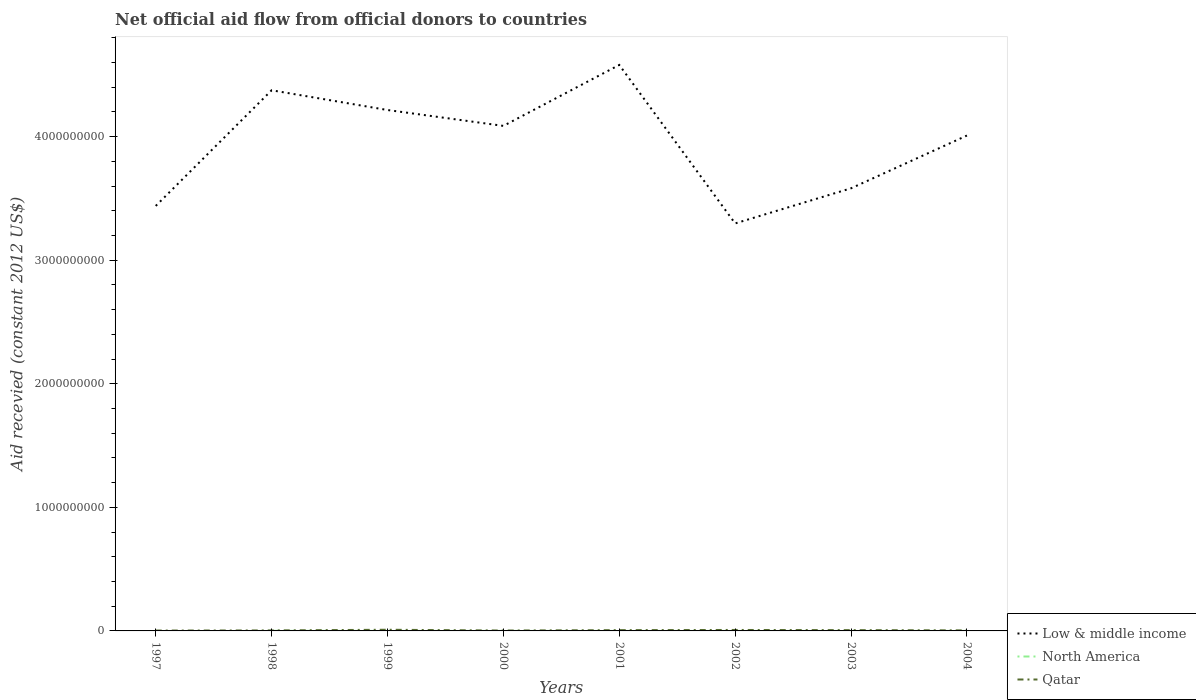Does the line corresponding to North America intersect with the line corresponding to Qatar?
Give a very brief answer. No. Across all years, what is the maximum total aid received in Qatar?
Make the answer very short. 2.98e+06. What is the total total aid received in Low & middle income in the graph?
Your response must be concise. 1.29e+08. What is the difference between the highest and the second highest total aid received in Qatar?
Your answer should be very brief. 6.53e+06. What is the difference between the highest and the lowest total aid received in Qatar?
Offer a very short reply. 4. Is the total aid received in Low & middle income strictly greater than the total aid received in North America over the years?
Your answer should be compact. No. How many years are there in the graph?
Give a very brief answer. 8. How many legend labels are there?
Ensure brevity in your answer.  3. What is the title of the graph?
Offer a very short reply. Net official aid flow from official donors to countries. What is the label or title of the Y-axis?
Ensure brevity in your answer.  Aid recevied (constant 2012 US$). What is the Aid recevied (constant 2012 US$) of Low & middle income in 1997?
Provide a short and direct response. 3.44e+09. What is the Aid recevied (constant 2012 US$) of North America in 1997?
Keep it short and to the point. 0. What is the Aid recevied (constant 2012 US$) of Qatar in 1997?
Offer a terse response. 2.98e+06. What is the Aid recevied (constant 2012 US$) in Low & middle income in 1998?
Your answer should be compact. 4.38e+09. What is the Aid recevied (constant 2012 US$) in North America in 1998?
Ensure brevity in your answer.  7.40e+05. What is the Aid recevied (constant 2012 US$) in Qatar in 1998?
Keep it short and to the point. 3.90e+06. What is the Aid recevied (constant 2012 US$) of Low & middle income in 1999?
Your response must be concise. 4.22e+09. What is the Aid recevied (constant 2012 US$) of North America in 1999?
Provide a succinct answer. 1.30e+05. What is the Aid recevied (constant 2012 US$) in Qatar in 1999?
Provide a succinct answer. 9.51e+06. What is the Aid recevied (constant 2012 US$) of Low & middle income in 2000?
Provide a succinct answer. 4.09e+09. What is the Aid recevied (constant 2012 US$) of Qatar in 2000?
Your answer should be very brief. 3.14e+06. What is the Aid recevied (constant 2012 US$) of Low & middle income in 2001?
Make the answer very short. 4.58e+09. What is the Aid recevied (constant 2012 US$) of North America in 2001?
Ensure brevity in your answer.  4.00e+04. What is the Aid recevied (constant 2012 US$) of Qatar in 2001?
Your answer should be compact. 6.30e+06. What is the Aid recevied (constant 2012 US$) of Low & middle income in 2002?
Offer a terse response. 3.30e+09. What is the Aid recevied (constant 2012 US$) in North America in 2002?
Offer a terse response. 3.00e+04. What is the Aid recevied (constant 2012 US$) of Qatar in 2002?
Offer a terse response. 7.79e+06. What is the Aid recevied (constant 2012 US$) of Low & middle income in 2003?
Offer a very short reply. 3.58e+09. What is the Aid recevied (constant 2012 US$) of North America in 2003?
Ensure brevity in your answer.  4.00e+04. What is the Aid recevied (constant 2012 US$) in Qatar in 2003?
Provide a short and direct response. 6.38e+06. What is the Aid recevied (constant 2012 US$) of Low & middle income in 2004?
Your response must be concise. 4.01e+09. What is the Aid recevied (constant 2012 US$) of Qatar in 2004?
Keep it short and to the point. 4.35e+06. Across all years, what is the maximum Aid recevied (constant 2012 US$) of Low & middle income?
Provide a succinct answer. 4.58e+09. Across all years, what is the maximum Aid recevied (constant 2012 US$) in North America?
Provide a short and direct response. 7.40e+05. Across all years, what is the maximum Aid recevied (constant 2012 US$) in Qatar?
Your response must be concise. 9.51e+06. Across all years, what is the minimum Aid recevied (constant 2012 US$) in Low & middle income?
Offer a terse response. 3.30e+09. Across all years, what is the minimum Aid recevied (constant 2012 US$) of North America?
Offer a terse response. 0. Across all years, what is the minimum Aid recevied (constant 2012 US$) of Qatar?
Give a very brief answer. 2.98e+06. What is the total Aid recevied (constant 2012 US$) of Low & middle income in the graph?
Offer a very short reply. 3.16e+1. What is the total Aid recevied (constant 2012 US$) in North America in the graph?
Your answer should be very brief. 1.20e+06. What is the total Aid recevied (constant 2012 US$) of Qatar in the graph?
Keep it short and to the point. 4.44e+07. What is the difference between the Aid recevied (constant 2012 US$) in Low & middle income in 1997 and that in 1998?
Ensure brevity in your answer.  -9.36e+08. What is the difference between the Aid recevied (constant 2012 US$) of Qatar in 1997 and that in 1998?
Give a very brief answer. -9.20e+05. What is the difference between the Aid recevied (constant 2012 US$) of Low & middle income in 1997 and that in 1999?
Offer a very short reply. -7.76e+08. What is the difference between the Aid recevied (constant 2012 US$) in Qatar in 1997 and that in 1999?
Make the answer very short. -6.53e+06. What is the difference between the Aid recevied (constant 2012 US$) in Low & middle income in 1997 and that in 2000?
Make the answer very short. -6.48e+08. What is the difference between the Aid recevied (constant 2012 US$) of Qatar in 1997 and that in 2000?
Offer a terse response. -1.60e+05. What is the difference between the Aid recevied (constant 2012 US$) of Low & middle income in 1997 and that in 2001?
Your response must be concise. -1.14e+09. What is the difference between the Aid recevied (constant 2012 US$) of Qatar in 1997 and that in 2001?
Your answer should be very brief. -3.32e+06. What is the difference between the Aid recevied (constant 2012 US$) in Low & middle income in 1997 and that in 2002?
Offer a very short reply. 1.42e+08. What is the difference between the Aid recevied (constant 2012 US$) in Qatar in 1997 and that in 2002?
Offer a very short reply. -4.81e+06. What is the difference between the Aid recevied (constant 2012 US$) of Low & middle income in 1997 and that in 2003?
Make the answer very short. -1.43e+08. What is the difference between the Aid recevied (constant 2012 US$) of Qatar in 1997 and that in 2003?
Offer a very short reply. -3.40e+06. What is the difference between the Aid recevied (constant 2012 US$) of Low & middle income in 1997 and that in 2004?
Provide a succinct answer. -5.70e+08. What is the difference between the Aid recevied (constant 2012 US$) in Qatar in 1997 and that in 2004?
Keep it short and to the point. -1.37e+06. What is the difference between the Aid recevied (constant 2012 US$) of Low & middle income in 1998 and that in 1999?
Offer a very short reply. 1.60e+08. What is the difference between the Aid recevied (constant 2012 US$) in Qatar in 1998 and that in 1999?
Provide a short and direct response. -5.61e+06. What is the difference between the Aid recevied (constant 2012 US$) in Low & middle income in 1998 and that in 2000?
Provide a short and direct response. 2.88e+08. What is the difference between the Aid recevied (constant 2012 US$) in North America in 1998 and that in 2000?
Make the answer very short. 6.30e+05. What is the difference between the Aid recevied (constant 2012 US$) of Qatar in 1998 and that in 2000?
Your response must be concise. 7.60e+05. What is the difference between the Aid recevied (constant 2012 US$) of Low & middle income in 1998 and that in 2001?
Your answer should be compact. -2.05e+08. What is the difference between the Aid recevied (constant 2012 US$) of Qatar in 1998 and that in 2001?
Give a very brief answer. -2.40e+06. What is the difference between the Aid recevied (constant 2012 US$) in Low & middle income in 1998 and that in 2002?
Your response must be concise. 1.08e+09. What is the difference between the Aid recevied (constant 2012 US$) in North America in 1998 and that in 2002?
Keep it short and to the point. 7.10e+05. What is the difference between the Aid recevied (constant 2012 US$) in Qatar in 1998 and that in 2002?
Offer a very short reply. -3.89e+06. What is the difference between the Aid recevied (constant 2012 US$) in Low & middle income in 1998 and that in 2003?
Offer a terse response. 7.93e+08. What is the difference between the Aid recevied (constant 2012 US$) of Qatar in 1998 and that in 2003?
Make the answer very short. -2.48e+06. What is the difference between the Aid recevied (constant 2012 US$) of Low & middle income in 1998 and that in 2004?
Your answer should be very brief. 3.66e+08. What is the difference between the Aid recevied (constant 2012 US$) in North America in 1998 and that in 2004?
Keep it short and to the point. 6.30e+05. What is the difference between the Aid recevied (constant 2012 US$) in Qatar in 1998 and that in 2004?
Ensure brevity in your answer.  -4.50e+05. What is the difference between the Aid recevied (constant 2012 US$) of Low & middle income in 1999 and that in 2000?
Ensure brevity in your answer.  1.29e+08. What is the difference between the Aid recevied (constant 2012 US$) of Qatar in 1999 and that in 2000?
Your response must be concise. 6.37e+06. What is the difference between the Aid recevied (constant 2012 US$) of Low & middle income in 1999 and that in 2001?
Provide a short and direct response. -3.65e+08. What is the difference between the Aid recevied (constant 2012 US$) in North America in 1999 and that in 2001?
Ensure brevity in your answer.  9.00e+04. What is the difference between the Aid recevied (constant 2012 US$) in Qatar in 1999 and that in 2001?
Make the answer very short. 3.21e+06. What is the difference between the Aid recevied (constant 2012 US$) in Low & middle income in 1999 and that in 2002?
Make the answer very short. 9.18e+08. What is the difference between the Aid recevied (constant 2012 US$) in North America in 1999 and that in 2002?
Ensure brevity in your answer.  1.00e+05. What is the difference between the Aid recevied (constant 2012 US$) of Qatar in 1999 and that in 2002?
Your answer should be very brief. 1.72e+06. What is the difference between the Aid recevied (constant 2012 US$) in Low & middle income in 1999 and that in 2003?
Ensure brevity in your answer.  6.34e+08. What is the difference between the Aid recevied (constant 2012 US$) of North America in 1999 and that in 2003?
Ensure brevity in your answer.  9.00e+04. What is the difference between the Aid recevied (constant 2012 US$) of Qatar in 1999 and that in 2003?
Provide a short and direct response. 3.13e+06. What is the difference between the Aid recevied (constant 2012 US$) of Low & middle income in 1999 and that in 2004?
Offer a terse response. 2.07e+08. What is the difference between the Aid recevied (constant 2012 US$) in North America in 1999 and that in 2004?
Offer a very short reply. 2.00e+04. What is the difference between the Aid recevied (constant 2012 US$) of Qatar in 1999 and that in 2004?
Offer a terse response. 5.16e+06. What is the difference between the Aid recevied (constant 2012 US$) in Low & middle income in 2000 and that in 2001?
Keep it short and to the point. -4.93e+08. What is the difference between the Aid recevied (constant 2012 US$) in Qatar in 2000 and that in 2001?
Provide a succinct answer. -3.16e+06. What is the difference between the Aid recevied (constant 2012 US$) of Low & middle income in 2000 and that in 2002?
Give a very brief answer. 7.89e+08. What is the difference between the Aid recevied (constant 2012 US$) in Qatar in 2000 and that in 2002?
Make the answer very short. -4.65e+06. What is the difference between the Aid recevied (constant 2012 US$) of Low & middle income in 2000 and that in 2003?
Keep it short and to the point. 5.05e+08. What is the difference between the Aid recevied (constant 2012 US$) in Qatar in 2000 and that in 2003?
Provide a short and direct response. -3.24e+06. What is the difference between the Aid recevied (constant 2012 US$) of Low & middle income in 2000 and that in 2004?
Provide a short and direct response. 7.80e+07. What is the difference between the Aid recevied (constant 2012 US$) of North America in 2000 and that in 2004?
Make the answer very short. 0. What is the difference between the Aid recevied (constant 2012 US$) of Qatar in 2000 and that in 2004?
Provide a short and direct response. -1.21e+06. What is the difference between the Aid recevied (constant 2012 US$) of Low & middle income in 2001 and that in 2002?
Your response must be concise. 1.28e+09. What is the difference between the Aid recevied (constant 2012 US$) in Qatar in 2001 and that in 2002?
Provide a succinct answer. -1.49e+06. What is the difference between the Aid recevied (constant 2012 US$) of Low & middle income in 2001 and that in 2003?
Ensure brevity in your answer.  9.98e+08. What is the difference between the Aid recevied (constant 2012 US$) in North America in 2001 and that in 2003?
Provide a short and direct response. 0. What is the difference between the Aid recevied (constant 2012 US$) of Qatar in 2001 and that in 2003?
Ensure brevity in your answer.  -8.00e+04. What is the difference between the Aid recevied (constant 2012 US$) of Low & middle income in 2001 and that in 2004?
Ensure brevity in your answer.  5.71e+08. What is the difference between the Aid recevied (constant 2012 US$) of North America in 2001 and that in 2004?
Provide a short and direct response. -7.00e+04. What is the difference between the Aid recevied (constant 2012 US$) in Qatar in 2001 and that in 2004?
Offer a terse response. 1.95e+06. What is the difference between the Aid recevied (constant 2012 US$) of Low & middle income in 2002 and that in 2003?
Make the answer very short. -2.84e+08. What is the difference between the Aid recevied (constant 2012 US$) of Qatar in 2002 and that in 2003?
Your answer should be very brief. 1.41e+06. What is the difference between the Aid recevied (constant 2012 US$) of Low & middle income in 2002 and that in 2004?
Your answer should be very brief. -7.11e+08. What is the difference between the Aid recevied (constant 2012 US$) of North America in 2002 and that in 2004?
Give a very brief answer. -8.00e+04. What is the difference between the Aid recevied (constant 2012 US$) in Qatar in 2002 and that in 2004?
Your answer should be very brief. 3.44e+06. What is the difference between the Aid recevied (constant 2012 US$) of Low & middle income in 2003 and that in 2004?
Offer a terse response. -4.27e+08. What is the difference between the Aid recevied (constant 2012 US$) in North America in 2003 and that in 2004?
Your answer should be very brief. -7.00e+04. What is the difference between the Aid recevied (constant 2012 US$) in Qatar in 2003 and that in 2004?
Offer a very short reply. 2.03e+06. What is the difference between the Aid recevied (constant 2012 US$) in Low & middle income in 1997 and the Aid recevied (constant 2012 US$) in North America in 1998?
Your response must be concise. 3.44e+09. What is the difference between the Aid recevied (constant 2012 US$) of Low & middle income in 1997 and the Aid recevied (constant 2012 US$) of Qatar in 1998?
Provide a succinct answer. 3.44e+09. What is the difference between the Aid recevied (constant 2012 US$) in Low & middle income in 1997 and the Aid recevied (constant 2012 US$) in North America in 1999?
Your response must be concise. 3.44e+09. What is the difference between the Aid recevied (constant 2012 US$) of Low & middle income in 1997 and the Aid recevied (constant 2012 US$) of Qatar in 1999?
Your answer should be compact. 3.43e+09. What is the difference between the Aid recevied (constant 2012 US$) of Low & middle income in 1997 and the Aid recevied (constant 2012 US$) of North America in 2000?
Your answer should be compact. 3.44e+09. What is the difference between the Aid recevied (constant 2012 US$) of Low & middle income in 1997 and the Aid recevied (constant 2012 US$) of Qatar in 2000?
Make the answer very short. 3.44e+09. What is the difference between the Aid recevied (constant 2012 US$) of Low & middle income in 1997 and the Aid recevied (constant 2012 US$) of North America in 2001?
Give a very brief answer. 3.44e+09. What is the difference between the Aid recevied (constant 2012 US$) of Low & middle income in 1997 and the Aid recevied (constant 2012 US$) of Qatar in 2001?
Offer a terse response. 3.43e+09. What is the difference between the Aid recevied (constant 2012 US$) of Low & middle income in 1997 and the Aid recevied (constant 2012 US$) of North America in 2002?
Ensure brevity in your answer.  3.44e+09. What is the difference between the Aid recevied (constant 2012 US$) in Low & middle income in 1997 and the Aid recevied (constant 2012 US$) in Qatar in 2002?
Your response must be concise. 3.43e+09. What is the difference between the Aid recevied (constant 2012 US$) of Low & middle income in 1997 and the Aid recevied (constant 2012 US$) of North America in 2003?
Offer a very short reply. 3.44e+09. What is the difference between the Aid recevied (constant 2012 US$) in Low & middle income in 1997 and the Aid recevied (constant 2012 US$) in Qatar in 2003?
Keep it short and to the point. 3.43e+09. What is the difference between the Aid recevied (constant 2012 US$) in Low & middle income in 1997 and the Aid recevied (constant 2012 US$) in North America in 2004?
Your answer should be compact. 3.44e+09. What is the difference between the Aid recevied (constant 2012 US$) in Low & middle income in 1997 and the Aid recevied (constant 2012 US$) in Qatar in 2004?
Keep it short and to the point. 3.43e+09. What is the difference between the Aid recevied (constant 2012 US$) of Low & middle income in 1998 and the Aid recevied (constant 2012 US$) of North America in 1999?
Your answer should be very brief. 4.38e+09. What is the difference between the Aid recevied (constant 2012 US$) of Low & middle income in 1998 and the Aid recevied (constant 2012 US$) of Qatar in 1999?
Make the answer very short. 4.37e+09. What is the difference between the Aid recevied (constant 2012 US$) in North America in 1998 and the Aid recevied (constant 2012 US$) in Qatar in 1999?
Keep it short and to the point. -8.77e+06. What is the difference between the Aid recevied (constant 2012 US$) of Low & middle income in 1998 and the Aid recevied (constant 2012 US$) of North America in 2000?
Provide a succinct answer. 4.38e+09. What is the difference between the Aid recevied (constant 2012 US$) in Low & middle income in 1998 and the Aid recevied (constant 2012 US$) in Qatar in 2000?
Provide a succinct answer. 4.37e+09. What is the difference between the Aid recevied (constant 2012 US$) of North America in 1998 and the Aid recevied (constant 2012 US$) of Qatar in 2000?
Offer a terse response. -2.40e+06. What is the difference between the Aid recevied (constant 2012 US$) of Low & middle income in 1998 and the Aid recevied (constant 2012 US$) of North America in 2001?
Your answer should be compact. 4.38e+09. What is the difference between the Aid recevied (constant 2012 US$) in Low & middle income in 1998 and the Aid recevied (constant 2012 US$) in Qatar in 2001?
Provide a short and direct response. 4.37e+09. What is the difference between the Aid recevied (constant 2012 US$) of North America in 1998 and the Aid recevied (constant 2012 US$) of Qatar in 2001?
Your response must be concise. -5.56e+06. What is the difference between the Aid recevied (constant 2012 US$) in Low & middle income in 1998 and the Aid recevied (constant 2012 US$) in North America in 2002?
Ensure brevity in your answer.  4.38e+09. What is the difference between the Aid recevied (constant 2012 US$) in Low & middle income in 1998 and the Aid recevied (constant 2012 US$) in Qatar in 2002?
Offer a very short reply. 4.37e+09. What is the difference between the Aid recevied (constant 2012 US$) of North America in 1998 and the Aid recevied (constant 2012 US$) of Qatar in 2002?
Offer a very short reply. -7.05e+06. What is the difference between the Aid recevied (constant 2012 US$) of Low & middle income in 1998 and the Aid recevied (constant 2012 US$) of North America in 2003?
Ensure brevity in your answer.  4.38e+09. What is the difference between the Aid recevied (constant 2012 US$) of Low & middle income in 1998 and the Aid recevied (constant 2012 US$) of Qatar in 2003?
Offer a very short reply. 4.37e+09. What is the difference between the Aid recevied (constant 2012 US$) of North America in 1998 and the Aid recevied (constant 2012 US$) of Qatar in 2003?
Your answer should be very brief. -5.64e+06. What is the difference between the Aid recevied (constant 2012 US$) in Low & middle income in 1998 and the Aid recevied (constant 2012 US$) in North America in 2004?
Ensure brevity in your answer.  4.38e+09. What is the difference between the Aid recevied (constant 2012 US$) of Low & middle income in 1998 and the Aid recevied (constant 2012 US$) of Qatar in 2004?
Your answer should be very brief. 4.37e+09. What is the difference between the Aid recevied (constant 2012 US$) in North America in 1998 and the Aid recevied (constant 2012 US$) in Qatar in 2004?
Offer a very short reply. -3.61e+06. What is the difference between the Aid recevied (constant 2012 US$) in Low & middle income in 1999 and the Aid recevied (constant 2012 US$) in North America in 2000?
Provide a succinct answer. 4.22e+09. What is the difference between the Aid recevied (constant 2012 US$) of Low & middle income in 1999 and the Aid recevied (constant 2012 US$) of Qatar in 2000?
Your answer should be compact. 4.21e+09. What is the difference between the Aid recevied (constant 2012 US$) in North America in 1999 and the Aid recevied (constant 2012 US$) in Qatar in 2000?
Your answer should be very brief. -3.01e+06. What is the difference between the Aid recevied (constant 2012 US$) in Low & middle income in 1999 and the Aid recevied (constant 2012 US$) in North America in 2001?
Make the answer very short. 4.22e+09. What is the difference between the Aid recevied (constant 2012 US$) of Low & middle income in 1999 and the Aid recevied (constant 2012 US$) of Qatar in 2001?
Offer a very short reply. 4.21e+09. What is the difference between the Aid recevied (constant 2012 US$) of North America in 1999 and the Aid recevied (constant 2012 US$) of Qatar in 2001?
Offer a very short reply. -6.17e+06. What is the difference between the Aid recevied (constant 2012 US$) in Low & middle income in 1999 and the Aid recevied (constant 2012 US$) in North America in 2002?
Your response must be concise. 4.22e+09. What is the difference between the Aid recevied (constant 2012 US$) of Low & middle income in 1999 and the Aid recevied (constant 2012 US$) of Qatar in 2002?
Give a very brief answer. 4.21e+09. What is the difference between the Aid recevied (constant 2012 US$) in North America in 1999 and the Aid recevied (constant 2012 US$) in Qatar in 2002?
Your answer should be compact. -7.66e+06. What is the difference between the Aid recevied (constant 2012 US$) in Low & middle income in 1999 and the Aid recevied (constant 2012 US$) in North America in 2003?
Give a very brief answer. 4.22e+09. What is the difference between the Aid recevied (constant 2012 US$) of Low & middle income in 1999 and the Aid recevied (constant 2012 US$) of Qatar in 2003?
Keep it short and to the point. 4.21e+09. What is the difference between the Aid recevied (constant 2012 US$) of North America in 1999 and the Aid recevied (constant 2012 US$) of Qatar in 2003?
Provide a succinct answer. -6.25e+06. What is the difference between the Aid recevied (constant 2012 US$) of Low & middle income in 1999 and the Aid recevied (constant 2012 US$) of North America in 2004?
Provide a succinct answer. 4.22e+09. What is the difference between the Aid recevied (constant 2012 US$) in Low & middle income in 1999 and the Aid recevied (constant 2012 US$) in Qatar in 2004?
Your answer should be very brief. 4.21e+09. What is the difference between the Aid recevied (constant 2012 US$) in North America in 1999 and the Aid recevied (constant 2012 US$) in Qatar in 2004?
Keep it short and to the point. -4.22e+06. What is the difference between the Aid recevied (constant 2012 US$) in Low & middle income in 2000 and the Aid recevied (constant 2012 US$) in North America in 2001?
Keep it short and to the point. 4.09e+09. What is the difference between the Aid recevied (constant 2012 US$) of Low & middle income in 2000 and the Aid recevied (constant 2012 US$) of Qatar in 2001?
Provide a short and direct response. 4.08e+09. What is the difference between the Aid recevied (constant 2012 US$) of North America in 2000 and the Aid recevied (constant 2012 US$) of Qatar in 2001?
Your answer should be compact. -6.19e+06. What is the difference between the Aid recevied (constant 2012 US$) in Low & middle income in 2000 and the Aid recevied (constant 2012 US$) in North America in 2002?
Offer a very short reply. 4.09e+09. What is the difference between the Aid recevied (constant 2012 US$) of Low & middle income in 2000 and the Aid recevied (constant 2012 US$) of Qatar in 2002?
Your response must be concise. 4.08e+09. What is the difference between the Aid recevied (constant 2012 US$) in North America in 2000 and the Aid recevied (constant 2012 US$) in Qatar in 2002?
Your answer should be compact. -7.68e+06. What is the difference between the Aid recevied (constant 2012 US$) in Low & middle income in 2000 and the Aid recevied (constant 2012 US$) in North America in 2003?
Your answer should be very brief. 4.09e+09. What is the difference between the Aid recevied (constant 2012 US$) of Low & middle income in 2000 and the Aid recevied (constant 2012 US$) of Qatar in 2003?
Your answer should be very brief. 4.08e+09. What is the difference between the Aid recevied (constant 2012 US$) in North America in 2000 and the Aid recevied (constant 2012 US$) in Qatar in 2003?
Ensure brevity in your answer.  -6.27e+06. What is the difference between the Aid recevied (constant 2012 US$) in Low & middle income in 2000 and the Aid recevied (constant 2012 US$) in North America in 2004?
Provide a short and direct response. 4.09e+09. What is the difference between the Aid recevied (constant 2012 US$) in Low & middle income in 2000 and the Aid recevied (constant 2012 US$) in Qatar in 2004?
Your answer should be very brief. 4.08e+09. What is the difference between the Aid recevied (constant 2012 US$) of North America in 2000 and the Aid recevied (constant 2012 US$) of Qatar in 2004?
Keep it short and to the point. -4.24e+06. What is the difference between the Aid recevied (constant 2012 US$) in Low & middle income in 2001 and the Aid recevied (constant 2012 US$) in North America in 2002?
Give a very brief answer. 4.58e+09. What is the difference between the Aid recevied (constant 2012 US$) of Low & middle income in 2001 and the Aid recevied (constant 2012 US$) of Qatar in 2002?
Your response must be concise. 4.57e+09. What is the difference between the Aid recevied (constant 2012 US$) of North America in 2001 and the Aid recevied (constant 2012 US$) of Qatar in 2002?
Your response must be concise. -7.75e+06. What is the difference between the Aid recevied (constant 2012 US$) of Low & middle income in 2001 and the Aid recevied (constant 2012 US$) of North America in 2003?
Offer a terse response. 4.58e+09. What is the difference between the Aid recevied (constant 2012 US$) in Low & middle income in 2001 and the Aid recevied (constant 2012 US$) in Qatar in 2003?
Offer a terse response. 4.57e+09. What is the difference between the Aid recevied (constant 2012 US$) of North America in 2001 and the Aid recevied (constant 2012 US$) of Qatar in 2003?
Offer a very short reply. -6.34e+06. What is the difference between the Aid recevied (constant 2012 US$) of Low & middle income in 2001 and the Aid recevied (constant 2012 US$) of North America in 2004?
Provide a short and direct response. 4.58e+09. What is the difference between the Aid recevied (constant 2012 US$) in Low & middle income in 2001 and the Aid recevied (constant 2012 US$) in Qatar in 2004?
Keep it short and to the point. 4.58e+09. What is the difference between the Aid recevied (constant 2012 US$) in North America in 2001 and the Aid recevied (constant 2012 US$) in Qatar in 2004?
Keep it short and to the point. -4.31e+06. What is the difference between the Aid recevied (constant 2012 US$) of Low & middle income in 2002 and the Aid recevied (constant 2012 US$) of North America in 2003?
Make the answer very short. 3.30e+09. What is the difference between the Aid recevied (constant 2012 US$) in Low & middle income in 2002 and the Aid recevied (constant 2012 US$) in Qatar in 2003?
Your answer should be very brief. 3.29e+09. What is the difference between the Aid recevied (constant 2012 US$) of North America in 2002 and the Aid recevied (constant 2012 US$) of Qatar in 2003?
Your answer should be compact. -6.35e+06. What is the difference between the Aid recevied (constant 2012 US$) in Low & middle income in 2002 and the Aid recevied (constant 2012 US$) in North America in 2004?
Give a very brief answer. 3.30e+09. What is the difference between the Aid recevied (constant 2012 US$) in Low & middle income in 2002 and the Aid recevied (constant 2012 US$) in Qatar in 2004?
Keep it short and to the point. 3.29e+09. What is the difference between the Aid recevied (constant 2012 US$) of North America in 2002 and the Aid recevied (constant 2012 US$) of Qatar in 2004?
Provide a short and direct response. -4.32e+06. What is the difference between the Aid recevied (constant 2012 US$) in Low & middle income in 2003 and the Aid recevied (constant 2012 US$) in North America in 2004?
Make the answer very short. 3.58e+09. What is the difference between the Aid recevied (constant 2012 US$) in Low & middle income in 2003 and the Aid recevied (constant 2012 US$) in Qatar in 2004?
Keep it short and to the point. 3.58e+09. What is the difference between the Aid recevied (constant 2012 US$) in North America in 2003 and the Aid recevied (constant 2012 US$) in Qatar in 2004?
Offer a terse response. -4.31e+06. What is the average Aid recevied (constant 2012 US$) of Low & middle income per year?
Make the answer very short. 3.95e+09. What is the average Aid recevied (constant 2012 US$) of North America per year?
Your answer should be compact. 1.50e+05. What is the average Aid recevied (constant 2012 US$) of Qatar per year?
Offer a very short reply. 5.54e+06. In the year 1997, what is the difference between the Aid recevied (constant 2012 US$) in Low & middle income and Aid recevied (constant 2012 US$) in Qatar?
Offer a terse response. 3.44e+09. In the year 1998, what is the difference between the Aid recevied (constant 2012 US$) of Low & middle income and Aid recevied (constant 2012 US$) of North America?
Offer a very short reply. 4.37e+09. In the year 1998, what is the difference between the Aid recevied (constant 2012 US$) of Low & middle income and Aid recevied (constant 2012 US$) of Qatar?
Make the answer very short. 4.37e+09. In the year 1998, what is the difference between the Aid recevied (constant 2012 US$) in North America and Aid recevied (constant 2012 US$) in Qatar?
Make the answer very short. -3.16e+06. In the year 1999, what is the difference between the Aid recevied (constant 2012 US$) of Low & middle income and Aid recevied (constant 2012 US$) of North America?
Offer a terse response. 4.22e+09. In the year 1999, what is the difference between the Aid recevied (constant 2012 US$) of Low & middle income and Aid recevied (constant 2012 US$) of Qatar?
Offer a very short reply. 4.21e+09. In the year 1999, what is the difference between the Aid recevied (constant 2012 US$) in North America and Aid recevied (constant 2012 US$) in Qatar?
Offer a terse response. -9.38e+06. In the year 2000, what is the difference between the Aid recevied (constant 2012 US$) in Low & middle income and Aid recevied (constant 2012 US$) in North America?
Provide a succinct answer. 4.09e+09. In the year 2000, what is the difference between the Aid recevied (constant 2012 US$) in Low & middle income and Aid recevied (constant 2012 US$) in Qatar?
Offer a terse response. 4.08e+09. In the year 2000, what is the difference between the Aid recevied (constant 2012 US$) in North America and Aid recevied (constant 2012 US$) in Qatar?
Provide a short and direct response. -3.03e+06. In the year 2001, what is the difference between the Aid recevied (constant 2012 US$) in Low & middle income and Aid recevied (constant 2012 US$) in North America?
Provide a short and direct response. 4.58e+09. In the year 2001, what is the difference between the Aid recevied (constant 2012 US$) in Low & middle income and Aid recevied (constant 2012 US$) in Qatar?
Give a very brief answer. 4.57e+09. In the year 2001, what is the difference between the Aid recevied (constant 2012 US$) in North America and Aid recevied (constant 2012 US$) in Qatar?
Provide a succinct answer. -6.26e+06. In the year 2002, what is the difference between the Aid recevied (constant 2012 US$) in Low & middle income and Aid recevied (constant 2012 US$) in North America?
Your response must be concise. 3.30e+09. In the year 2002, what is the difference between the Aid recevied (constant 2012 US$) of Low & middle income and Aid recevied (constant 2012 US$) of Qatar?
Offer a very short reply. 3.29e+09. In the year 2002, what is the difference between the Aid recevied (constant 2012 US$) in North America and Aid recevied (constant 2012 US$) in Qatar?
Your answer should be compact. -7.76e+06. In the year 2003, what is the difference between the Aid recevied (constant 2012 US$) in Low & middle income and Aid recevied (constant 2012 US$) in North America?
Offer a terse response. 3.58e+09. In the year 2003, what is the difference between the Aid recevied (constant 2012 US$) of Low & middle income and Aid recevied (constant 2012 US$) of Qatar?
Your answer should be compact. 3.58e+09. In the year 2003, what is the difference between the Aid recevied (constant 2012 US$) of North America and Aid recevied (constant 2012 US$) of Qatar?
Your answer should be very brief. -6.34e+06. In the year 2004, what is the difference between the Aid recevied (constant 2012 US$) of Low & middle income and Aid recevied (constant 2012 US$) of North America?
Your answer should be very brief. 4.01e+09. In the year 2004, what is the difference between the Aid recevied (constant 2012 US$) in Low & middle income and Aid recevied (constant 2012 US$) in Qatar?
Ensure brevity in your answer.  4.00e+09. In the year 2004, what is the difference between the Aid recevied (constant 2012 US$) of North America and Aid recevied (constant 2012 US$) of Qatar?
Give a very brief answer. -4.24e+06. What is the ratio of the Aid recevied (constant 2012 US$) of Low & middle income in 1997 to that in 1998?
Your response must be concise. 0.79. What is the ratio of the Aid recevied (constant 2012 US$) in Qatar in 1997 to that in 1998?
Offer a very short reply. 0.76. What is the ratio of the Aid recevied (constant 2012 US$) in Low & middle income in 1997 to that in 1999?
Your response must be concise. 0.82. What is the ratio of the Aid recevied (constant 2012 US$) of Qatar in 1997 to that in 1999?
Provide a succinct answer. 0.31. What is the ratio of the Aid recevied (constant 2012 US$) of Low & middle income in 1997 to that in 2000?
Provide a succinct answer. 0.84. What is the ratio of the Aid recevied (constant 2012 US$) of Qatar in 1997 to that in 2000?
Make the answer very short. 0.95. What is the ratio of the Aid recevied (constant 2012 US$) in Low & middle income in 1997 to that in 2001?
Provide a succinct answer. 0.75. What is the ratio of the Aid recevied (constant 2012 US$) of Qatar in 1997 to that in 2001?
Your response must be concise. 0.47. What is the ratio of the Aid recevied (constant 2012 US$) of Low & middle income in 1997 to that in 2002?
Make the answer very short. 1.04. What is the ratio of the Aid recevied (constant 2012 US$) of Qatar in 1997 to that in 2002?
Provide a succinct answer. 0.38. What is the ratio of the Aid recevied (constant 2012 US$) in Low & middle income in 1997 to that in 2003?
Your response must be concise. 0.96. What is the ratio of the Aid recevied (constant 2012 US$) of Qatar in 1997 to that in 2003?
Provide a short and direct response. 0.47. What is the ratio of the Aid recevied (constant 2012 US$) of Low & middle income in 1997 to that in 2004?
Make the answer very short. 0.86. What is the ratio of the Aid recevied (constant 2012 US$) of Qatar in 1997 to that in 2004?
Your answer should be compact. 0.69. What is the ratio of the Aid recevied (constant 2012 US$) of Low & middle income in 1998 to that in 1999?
Ensure brevity in your answer.  1.04. What is the ratio of the Aid recevied (constant 2012 US$) in North America in 1998 to that in 1999?
Offer a very short reply. 5.69. What is the ratio of the Aid recevied (constant 2012 US$) in Qatar in 1998 to that in 1999?
Keep it short and to the point. 0.41. What is the ratio of the Aid recevied (constant 2012 US$) of Low & middle income in 1998 to that in 2000?
Your answer should be very brief. 1.07. What is the ratio of the Aid recevied (constant 2012 US$) of North America in 1998 to that in 2000?
Offer a terse response. 6.73. What is the ratio of the Aid recevied (constant 2012 US$) of Qatar in 1998 to that in 2000?
Your answer should be very brief. 1.24. What is the ratio of the Aid recevied (constant 2012 US$) of Low & middle income in 1998 to that in 2001?
Provide a short and direct response. 0.96. What is the ratio of the Aid recevied (constant 2012 US$) of Qatar in 1998 to that in 2001?
Provide a succinct answer. 0.62. What is the ratio of the Aid recevied (constant 2012 US$) of Low & middle income in 1998 to that in 2002?
Ensure brevity in your answer.  1.33. What is the ratio of the Aid recevied (constant 2012 US$) of North America in 1998 to that in 2002?
Provide a short and direct response. 24.67. What is the ratio of the Aid recevied (constant 2012 US$) in Qatar in 1998 to that in 2002?
Offer a very short reply. 0.5. What is the ratio of the Aid recevied (constant 2012 US$) of Low & middle income in 1998 to that in 2003?
Ensure brevity in your answer.  1.22. What is the ratio of the Aid recevied (constant 2012 US$) in Qatar in 1998 to that in 2003?
Your response must be concise. 0.61. What is the ratio of the Aid recevied (constant 2012 US$) in Low & middle income in 1998 to that in 2004?
Keep it short and to the point. 1.09. What is the ratio of the Aid recevied (constant 2012 US$) of North America in 1998 to that in 2004?
Offer a very short reply. 6.73. What is the ratio of the Aid recevied (constant 2012 US$) of Qatar in 1998 to that in 2004?
Your answer should be compact. 0.9. What is the ratio of the Aid recevied (constant 2012 US$) in Low & middle income in 1999 to that in 2000?
Keep it short and to the point. 1.03. What is the ratio of the Aid recevied (constant 2012 US$) of North America in 1999 to that in 2000?
Your answer should be compact. 1.18. What is the ratio of the Aid recevied (constant 2012 US$) of Qatar in 1999 to that in 2000?
Your answer should be very brief. 3.03. What is the ratio of the Aid recevied (constant 2012 US$) of Low & middle income in 1999 to that in 2001?
Your answer should be very brief. 0.92. What is the ratio of the Aid recevied (constant 2012 US$) in North America in 1999 to that in 2001?
Your answer should be compact. 3.25. What is the ratio of the Aid recevied (constant 2012 US$) of Qatar in 1999 to that in 2001?
Offer a terse response. 1.51. What is the ratio of the Aid recevied (constant 2012 US$) in Low & middle income in 1999 to that in 2002?
Offer a very short reply. 1.28. What is the ratio of the Aid recevied (constant 2012 US$) of North America in 1999 to that in 2002?
Offer a terse response. 4.33. What is the ratio of the Aid recevied (constant 2012 US$) of Qatar in 1999 to that in 2002?
Your answer should be very brief. 1.22. What is the ratio of the Aid recevied (constant 2012 US$) of Low & middle income in 1999 to that in 2003?
Offer a terse response. 1.18. What is the ratio of the Aid recevied (constant 2012 US$) of North America in 1999 to that in 2003?
Keep it short and to the point. 3.25. What is the ratio of the Aid recevied (constant 2012 US$) in Qatar in 1999 to that in 2003?
Make the answer very short. 1.49. What is the ratio of the Aid recevied (constant 2012 US$) in Low & middle income in 1999 to that in 2004?
Keep it short and to the point. 1.05. What is the ratio of the Aid recevied (constant 2012 US$) of North America in 1999 to that in 2004?
Keep it short and to the point. 1.18. What is the ratio of the Aid recevied (constant 2012 US$) of Qatar in 1999 to that in 2004?
Offer a very short reply. 2.19. What is the ratio of the Aid recevied (constant 2012 US$) of Low & middle income in 2000 to that in 2001?
Make the answer very short. 0.89. What is the ratio of the Aid recevied (constant 2012 US$) of North America in 2000 to that in 2001?
Your response must be concise. 2.75. What is the ratio of the Aid recevied (constant 2012 US$) of Qatar in 2000 to that in 2001?
Give a very brief answer. 0.5. What is the ratio of the Aid recevied (constant 2012 US$) of Low & middle income in 2000 to that in 2002?
Offer a very short reply. 1.24. What is the ratio of the Aid recevied (constant 2012 US$) of North America in 2000 to that in 2002?
Ensure brevity in your answer.  3.67. What is the ratio of the Aid recevied (constant 2012 US$) of Qatar in 2000 to that in 2002?
Ensure brevity in your answer.  0.4. What is the ratio of the Aid recevied (constant 2012 US$) of Low & middle income in 2000 to that in 2003?
Give a very brief answer. 1.14. What is the ratio of the Aid recevied (constant 2012 US$) in North America in 2000 to that in 2003?
Ensure brevity in your answer.  2.75. What is the ratio of the Aid recevied (constant 2012 US$) in Qatar in 2000 to that in 2003?
Your answer should be compact. 0.49. What is the ratio of the Aid recevied (constant 2012 US$) of Low & middle income in 2000 to that in 2004?
Provide a succinct answer. 1.02. What is the ratio of the Aid recevied (constant 2012 US$) of North America in 2000 to that in 2004?
Ensure brevity in your answer.  1. What is the ratio of the Aid recevied (constant 2012 US$) of Qatar in 2000 to that in 2004?
Ensure brevity in your answer.  0.72. What is the ratio of the Aid recevied (constant 2012 US$) of Low & middle income in 2001 to that in 2002?
Keep it short and to the point. 1.39. What is the ratio of the Aid recevied (constant 2012 US$) of North America in 2001 to that in 2002?
Ensure brevity in your answer.  1.33. What is the ratio of the Aid recevied (constant 2012 US$) of Qatar in 2001 to that in 2002?
Provide a short and direct response. 0.81. What is the ratio of the Aid recevied (constant 2012 US$) in Low & middle income in 2001 to that in 2003?
Provide a succinct answer. 1.28. What is the ratio of the Aid recevied (constant 2012 US$) of North America in 2001 to that in 2003?
Your response must be concise. 1. What is the ratio of the Aid recevied (constant 2012 US$) of Qatar in 2001 to that in 2003?
Make the answer very short. 0.99. What is the ratio of the Aid recevied (constant 2012 US$) in Low & middle income in 2001 to that in 2004?
Provide a short and direct response. 1.14. What is the ratio of the Aid recevied (constant 2012 US$) in North America in 2001 to that in 2004?
Offer a very short reply. 0.36. What is the ratio of the Aid recevied (constant 2012 US$) of Qatar in 2001 to that in 2004?
Provide a succinct answer. 1.45. What is the ratio of the Aid recevied (constant 2012 US$) in Low & middle income in 2002 to that in 2003?
Make the answer very short. 0.92. What is the ratio of the Aid recevied (constant 2012 US$) in Qatar in 2002 to that in 2003?
Offer a terse response. 1.22. What is the ratio of the Aid recevied (constant 2012 US$) of Low & middle income in 2002 to that in 2004?
Offer a very short reply. 0.82. What is the ratio of the Aid recevied (constant 2012 US$) of North America in 2002 to that in 2004?
Offer a very short reply. 0.27. What is the ratio of the Aid recevied (constant 2012 US$) in Qatar in 2002 to that in 2004?
Make the answer very short. 1.79. What is the ratio of the Aid recevied (constant 2012 US$) of Low & middle income in 2003 to that in 2004?
Ensure brevity in your answer.  0.89. What is the ratio of the Aid recevied (constant 2012 US$) of North America in 2003 to that in 2004?
Offer a very short reply. 0.36. What is the ratio of the Aid recevied (constant 2012 US$) in Qatar in 2003 to that in 2004?
Your answer should be compact. 1.47. What is the difference between the highest and the second highest Aid recevied (constant 2012 US$) in Low & middle income?
Keep it short and to the point. 2.05e+08. What is the difference between the highest and the second highest Aid recevied (constant 2012 US$) of Qatar?
Offer a terse response. 1.72e+06. What is the difference between the highest and the lowest Aid recevied (constant 2012 US$) of Low & middle income?
Ensure brevity in your answer.  1.28e+09. What is the difference between the highest and the lowest Aid recevied (constant 2012 US$) of North America?
Give a very brief answer. 7.40e+05. What is the difference between the highest and the lowest Aid recevied (constant 2012 US$) of Qatar?
Offer a terse response. 6.53e+06. 